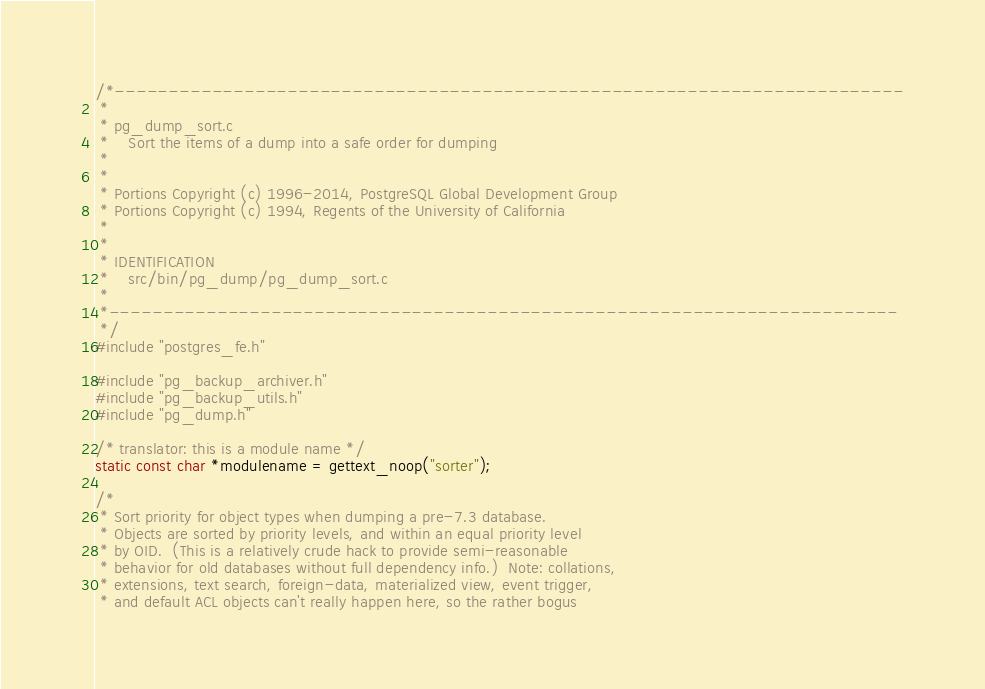<code> <loc_0><loc_0><loc_500><loc_500><_C_>/*-------------------------------------------------------------------------
 *
 * pg_dump_sort.c
 *	  Sort the items of a dump into a safe order for dumping
 *
 *
 * Portions Copyright (c) 1996-2014, PostgreSQL Global Development Group
 * Portions Copyright (c) 1994, Regents of the University of California
 *
 *
 * IDENTIFICATION
 *	  src/bin/pg_dump/pg_dump_sort.c
 *
 *-------------------------------------------------------------------------
 */
#include "postgres_fe.h"

#include "pg_backup_archiver.h"
#include "pg_backup_utils.h"
#include "pg_dump.h"

/* translator: this is a module name */
static const char *modulename = gettext_noop("sorter");

/*
 * Sort priority for object types when dumping a pre-7.3 database.
 * Objects are sorted by priority levels, and within an equal priority level
 * by OID.  (This is a relatively crude hack to provide semi-reasonable
 * behavior for old databases without full dependency info.)  Note: collations,
 * extensions, text search, foreign-data, materialized view, event trigger,
 * and default ACL objects can't really happen here, so the rather bogus</code> 